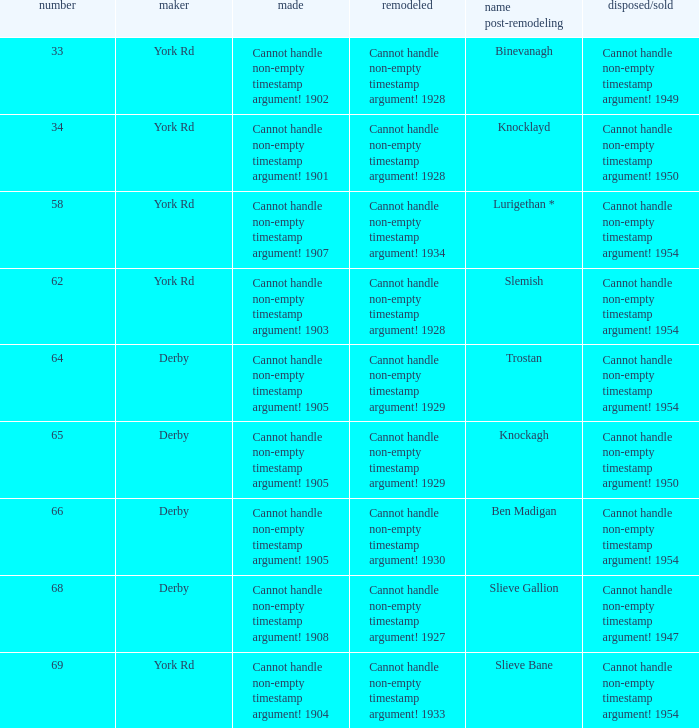Which Rebuilt has a Builder of derby, and a Name as rebuilt of ben madigan? Cannot handle non-empty timestamp argument! 1930. 